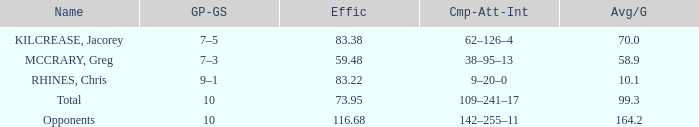What is the minimum efficiency with a 5 59.48. 